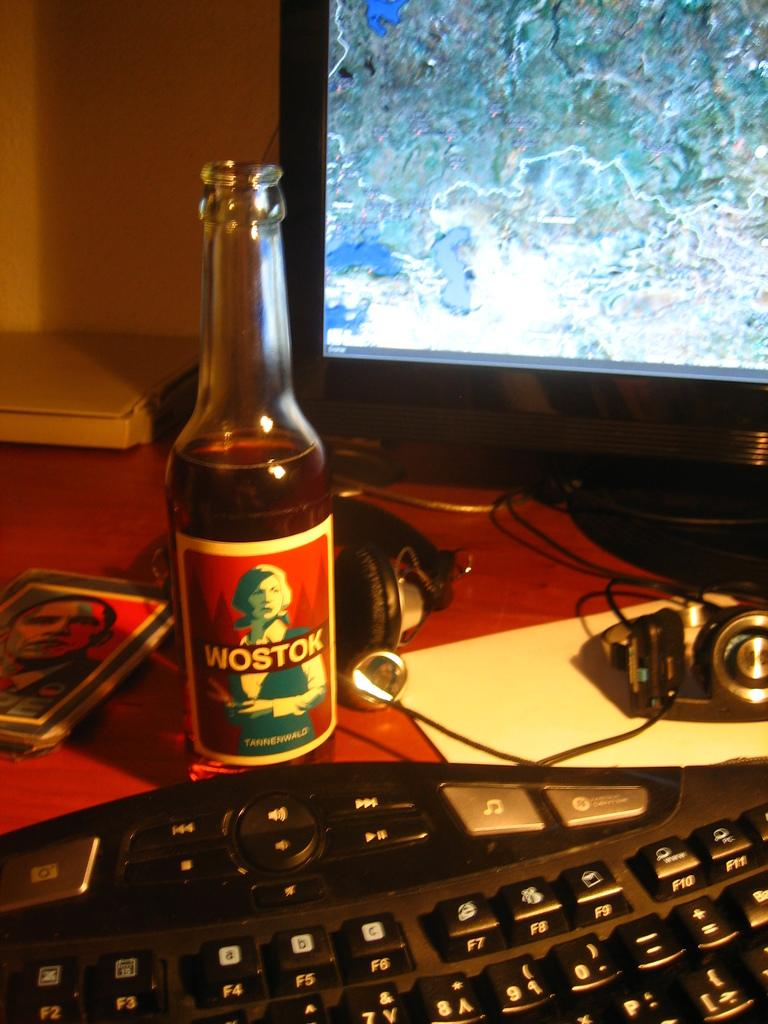<image>
Share a concise interpretation of the image provided. A bottle of Wostok I front of a computer keyboard. 